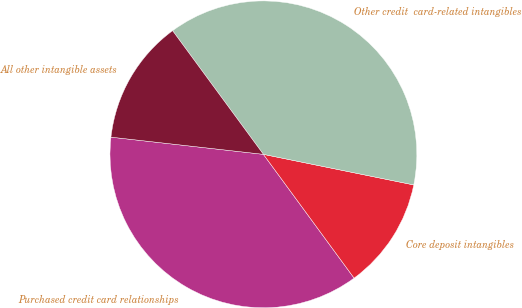Convert chart. <chart><loc_0><loc_0><loc_500><loc_500><pie_chart><fcel>Purchased credit card relationships<fcel>Core deposit intangibles<fcel>Other credit  card-related intangibles<fcel>All other intangible assets<nl><fcel>36.85%<fcel>11.74%<fcel>38.27%<fcel>13.13%<nl></chart> 